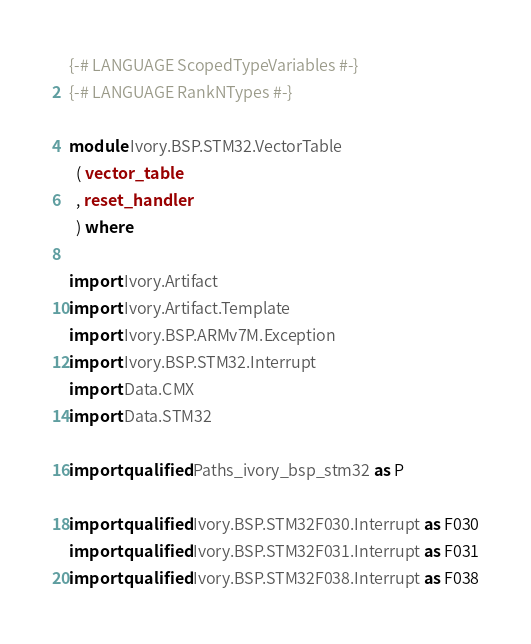Convert code to text. <code><loc_0><loc_0><loc_500><loc_500><_Haskell_>{-# LANGUAGE ScopedTypeVariables #-}
{-# LANGUAGE RankNTypes #-}

module Ivory.BSP.STM32.VectorTable
  ( vector_table
  , reset_handler
  ) where

import Ivory.Artifact
import Ivory.Artifact.Template
import Ivory.BSP.ARMv7M.Exception
import Ivory.BSP.STM32.Interrupt
import Data.CMX
import Data.STM32

import qualified Paths_ivory_bsp_stm32 as P

import qualified Ivory.BSP.STM32F030.Interrupt as F030
import qualified Ivory.BSP.STM32F031.Interrupt as F031
import qualified Ivory.BSP.STM32F038.Interrupt as F038</code> 